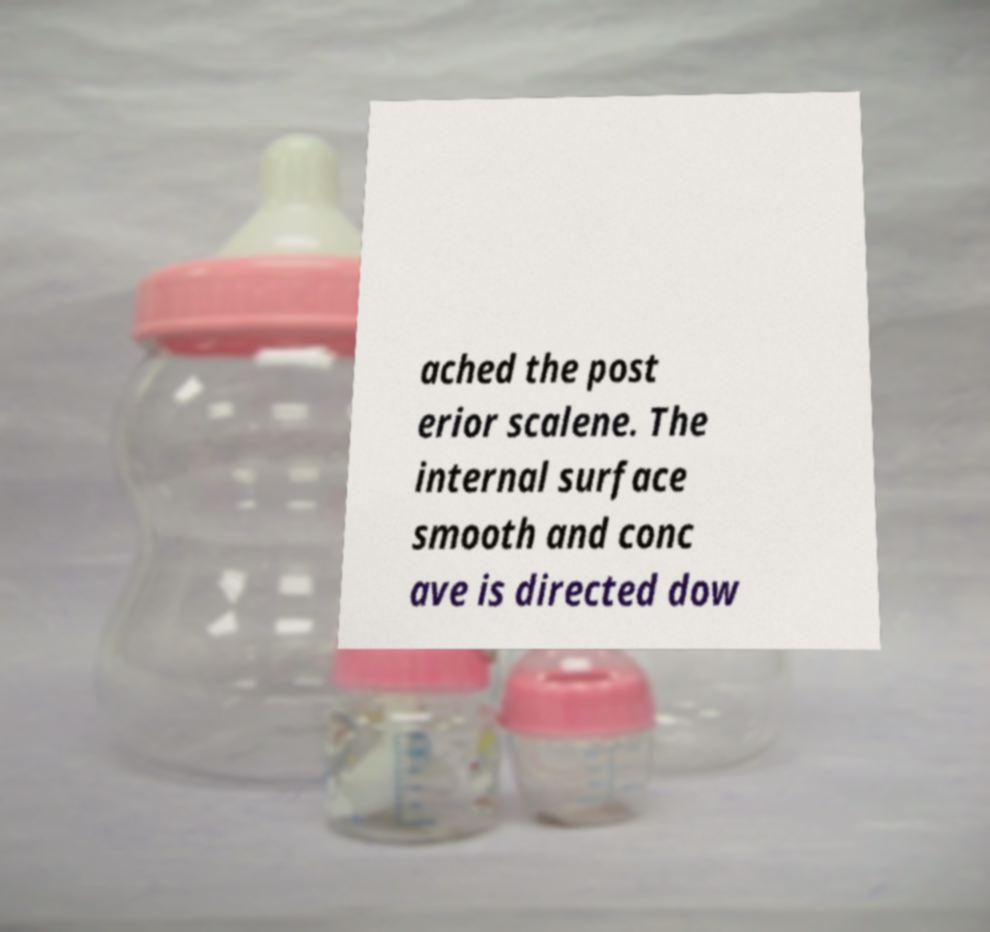Could you assist in decoding the text presented in this image and type it out clearly? ached the post erior scalene. The internal surface smooth and conc ave is directed dow 